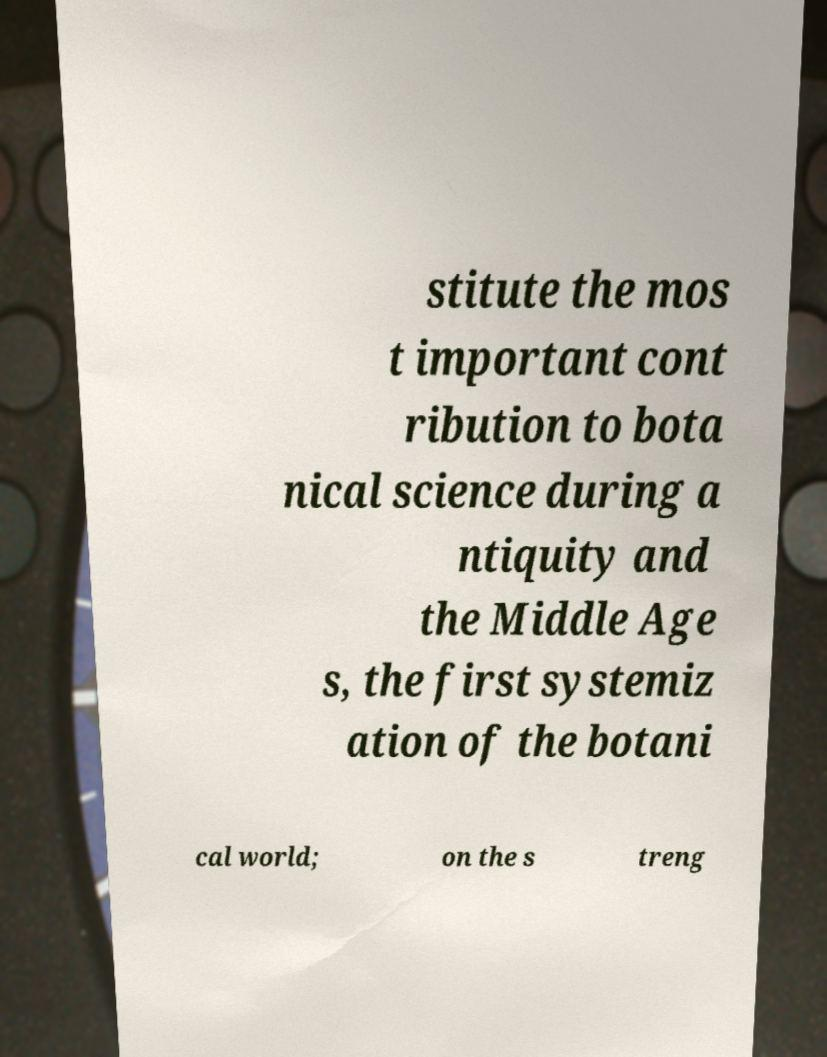Please identify and transcribe the text found in this image. stitute the mos t important cont ribution to bota nical science during a ntiquity and the Middle Age s, the first systemiz ation of the botani cal world; on the s treng 